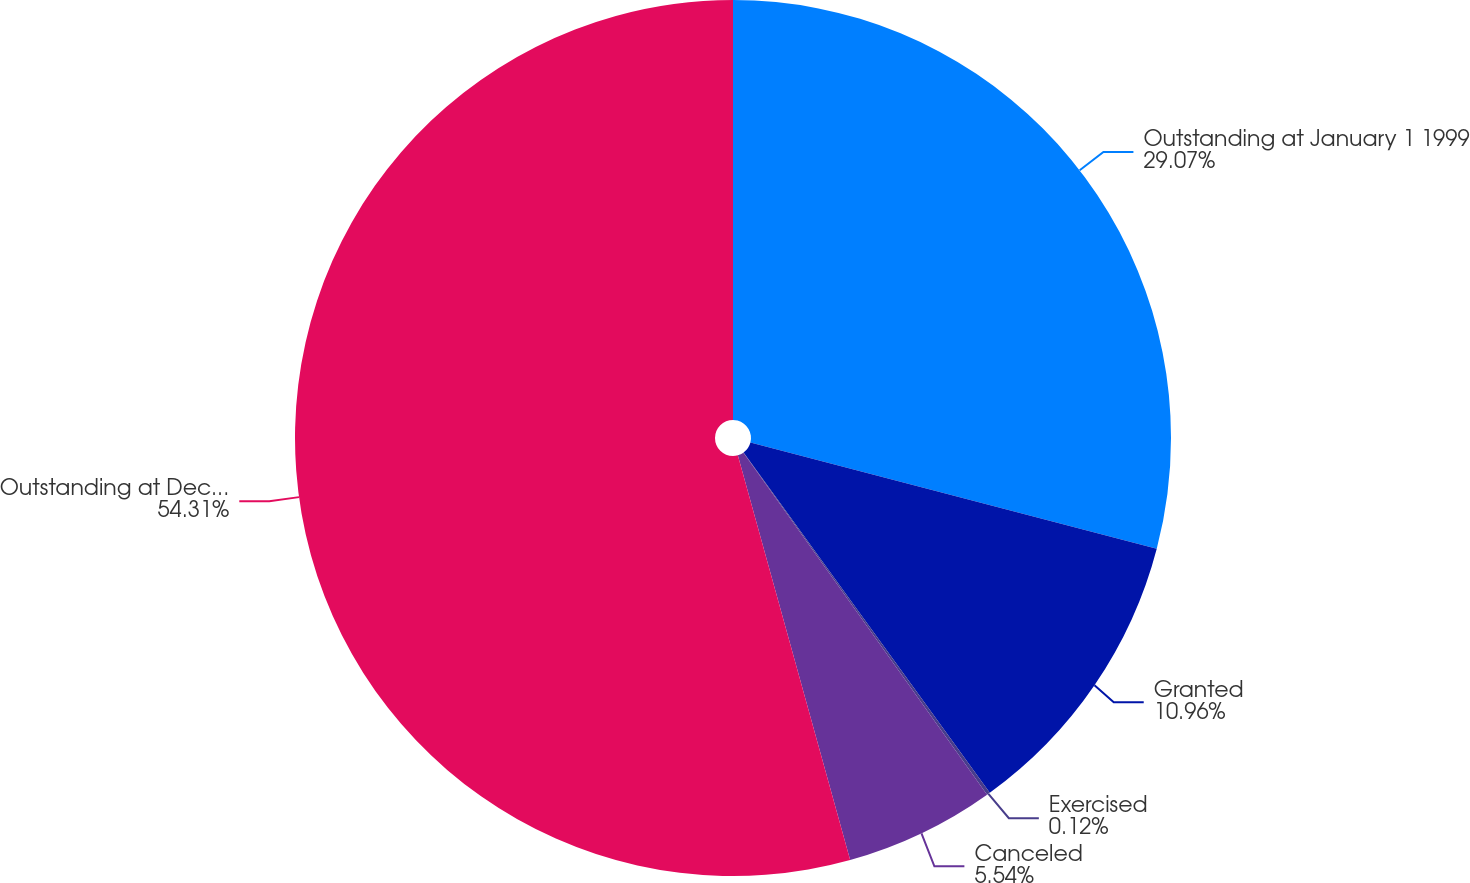<chart> <loc_0><loc_0><loc_500><loc_500><pie_chart><fcel>Outstanding at January 1 1999<fcel>Granted<fcel>Exercised<fcel>Canceled<fcel>Outstanding at December 31<nl><fcel>29.07%<fcel>10.96%<fcel>0.12%<fcel>5.54%<fcel>54.31%<nl></chart> 